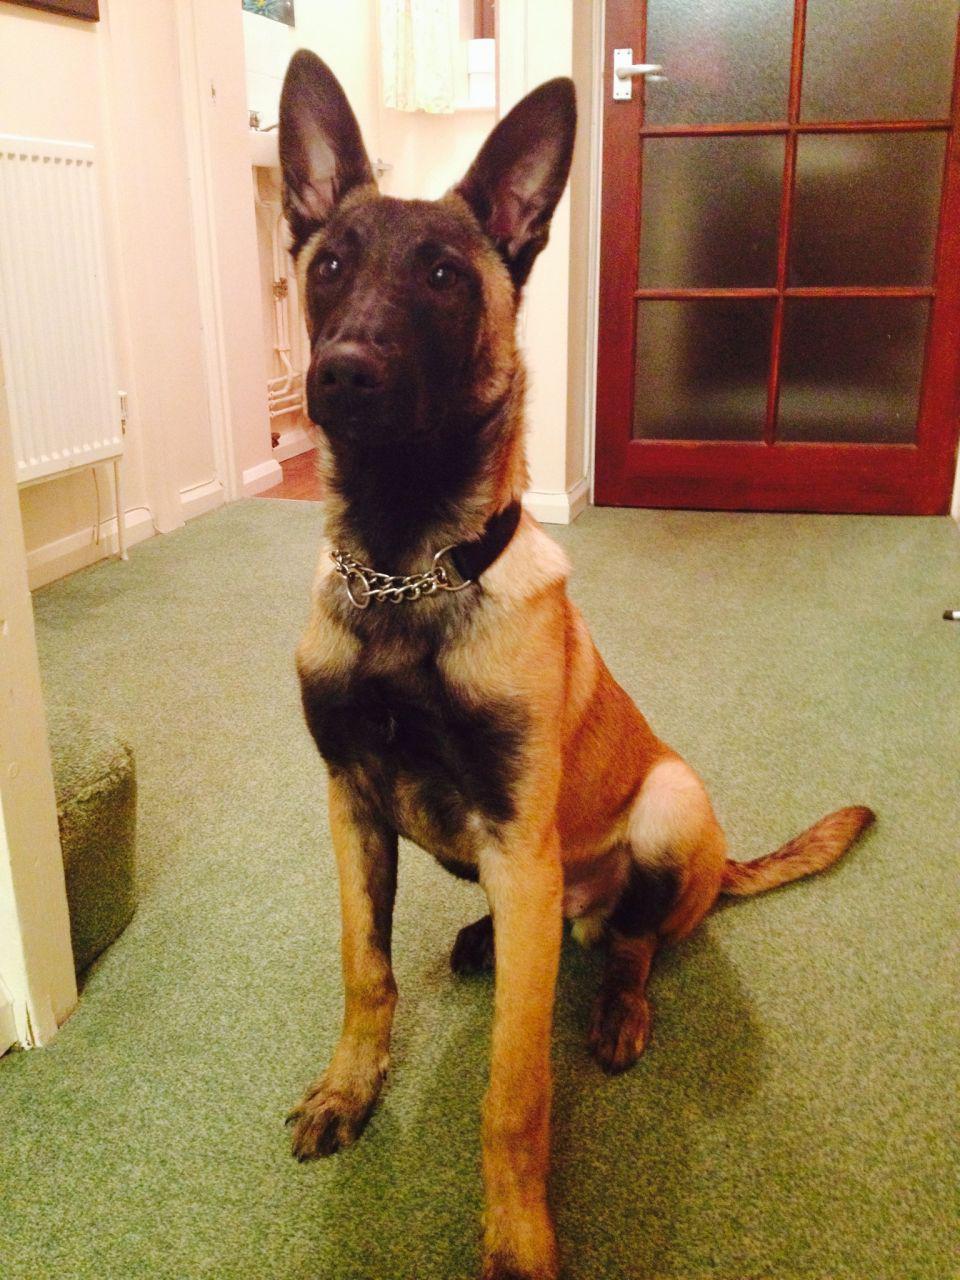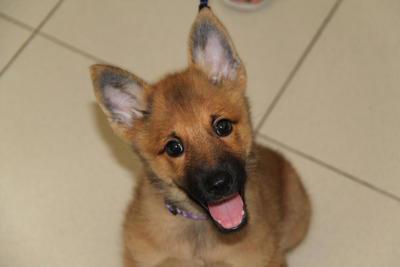The first image is the image on the left, the second image is the image on the right. For the images displayed, is the sentence "One dog is looking up." factually correct? Answer yes or no. Yes. 